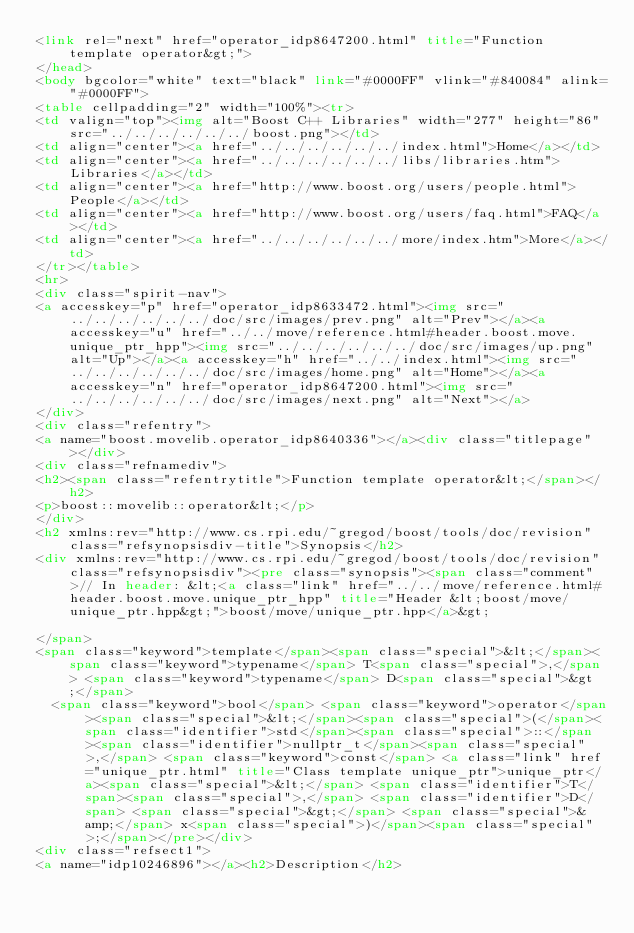Convert code to text. <code><loc_0><loc_0><loc_500><loc_500><_HTML_><link rel="next" href="operator_idp8647200.html" title="Function template operator&gt;">
</head>
<body bgcolor="white" text="black" link="#0000FF" vlink="#840084" alink="#0000FF">
<table cellpadding="2" width="100%"><tr>
<td valign="top"><img alt="Boost C++ Libraries" width="277" height="86" src="../../../../../../boost.png"></td>
<td align="center"><a href="../../../../../../index.html">Home</a></td>
<td align="center"><a href="../../../../../../libs/libraries.htm">Libraries</a></td>
<td align="center"><a href="http://www.boost.org/users/people.html">People</a></td>
<td align="center"><a href="http://www.boost.org/users/faq.html">FAQ</a></td>
<td align="center"><a href="../../../../../../more/index.htm">More</a></td>
</tr></table>
<hr>
<div class="spirit-nav">
<a accesskey="p" href="operator_idp8633472.html"><img src="../../../../../../doc/src/images/prev.png" alt="Prev"></a><a accesskey="u" href="../../move/reference.html#header.boost.move.unique_ptr_hpp"><img src="../../../../../../doc/src/images/up.png" alt="Up"></a><a accesskey="h" href="../../index.html"><img src="../../../../../../doc/src/images/home.png" alt="Home"></a><a accesskey="n" href="operator_idp8647200.html"><img src="../../../../../../doc/src/images/next.png" alt="Next"></a>
</div>
<div class="refentry">
<a name="boost.movelib.operator_idp8640336"></a><div class="titlepage"></div>
<div class="refnamediv">
<h2><span class="refentrytitle">Function template operator&lt;</span></h2>
<p>boost::movelib::operator&lt;</p>
</div>
<h2 xmlns:rev="http://www.cs.rpi.edu/~gregod/boost/tools/doc/revision" class="refsynopsisdiv-title">Synopsis</h2>
<div xmlns:rev="http://www.cs.rpi.edu/~gregod/boost/tools/doc/revision" class="refsynopsisdiv"><pre class="synopsis"><span class="comment">// In header: &lt;<a class="link" href="../../move/reference.html#header.boost.move.unique_ptr_hpp" title="Header &lt;boost/move/unique_ptr.hpp&gt;">boost/move/unique_ptr.hpp</a>&gt;

</span>
<span class="keyword">template</span><span class="special">&lt;</span><span class="keyword">typename</span> T<span class="special">,</span> <span class="keyword">typename</span> D<span class="special">&gt;</span> 
  <span class="keyword">bool</span> <span class="keyword">operator</span><span class="special">&lt;</span><span class="special">(</span><span class="identifier">std</span><span class="special">::</span><span class="identifier">nullptr_t</span><span class="special">,</span> <span class="keyword">const</span> <a class="link" href="unique_ptr.html" title="Class template unique_ptr">unique_ptr</a><span class="special">&lt;</span> <span class="identifier">T</span><span class="special">,</span> <span class="identifier">D</span> <span class="special">&gt;</span> <span class="special">&amp;</span> x<span class="special">)</span><span class="special">;</span></pre></div>
<div class="refsect1">
<a name="idp10246896"></a><h2>Description</h2></code> 